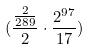<formula> <loc_0><loc_0><loc_500><loc_500>( \frac { \frac { 2 } { 2 8 9 } } { 2 } \cdot \frac { 2 ^ { 9 7 } } { 1 7 } )</formula> 